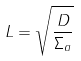<formula> <loc_0><loc_0><loc_500><loc_500>L = \sqrt { \frac { D } { \Sigma _ { a } } }</formula> 